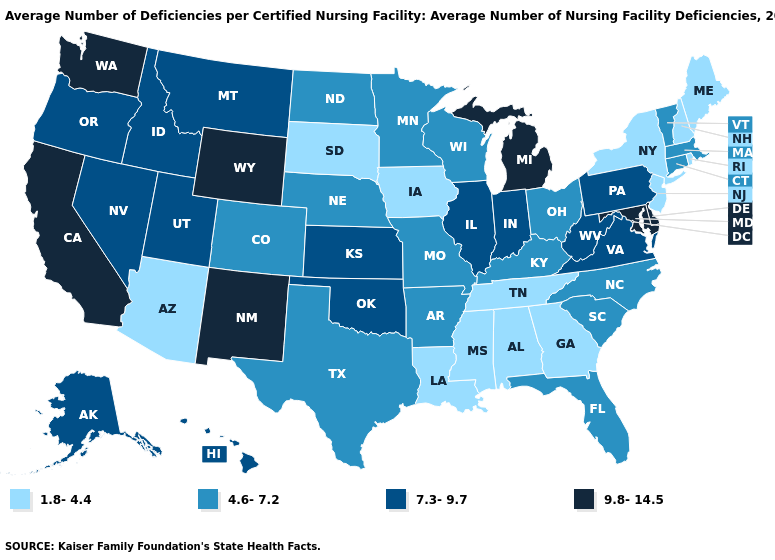Name the states that have a value in the range 7.3-9.7?
Answer briefly. Alaska, Hawaii, Idaho, Illinois, Indiana, Kansas, Montana, Nevada, Oklahoma, Oregon, Pennsylvania, Utah, Virginia, West Virginia. What is the lowest value in the Northeast?
Give a very brief answer. 1.8-4.4. Name the states that have a value in the range 4.6-7.2?
Concise answer only. Arkansas, Colorado, Connecticut, Florida, Kentucky, Massachusetts, Minnesota, Missouri, Nebraska, North Carolina, North Dakota, Ohio, South Carolina, Texas, Vermont, Wisconsin. Name the states that have a value in the range 9.8-14.5?
Concise answer only. California, Delaware, Maryland, Michigan, New Mexico, Washington, Wyoming. Which states have the lowest value in the Northeast?
Short answer required. Maine, New Hampshire, New Jersey, New York, Rhode Island. Which states hav the highest value in the South?
Short answer required. Delaware, Maryland. Name the states that have a value in the range 1.8-4.4?
Write a very short answer. Alabama, Arizona, Georgia, Iowa, Louisiana, Maine, Mississippi, New Hampshire, New Jersey, New York, Rhode Island, South Dakota, Tennessee. Name the states that have a value in the range 1.8-4.4?
Concise answer only. Alabama, Arizona, Georgia, Iowa, Louisiana, Maine, Mississippi, New Hampshire, New Jersey, New York, Rhode Island, South Dakota, Tennessee. What is the value of Colorado?
Quick response, please. 4.6-7.2. What is the value of Michigan?
Answer briefly. 9.8-14.5. Name the states that have a value in the range 1.8-4.4?
Answer briefly. Alabama, Arizona, Georgia, Iowa, Louisiana, Maine, Mississippi, New Hampshire, New Jersey, New York, Rhode Island, South Dakota, Tennessee. Which states have the lowest value in the MidWest?
Answer briefly. Iowa, South Dakota. What is the value of New Jersey?
Be succinct. 1.8-4.4. What is the value of Utah?
Be succinct. 7.3-9.7. Does the map have missing data?
Concise answer only. No. 